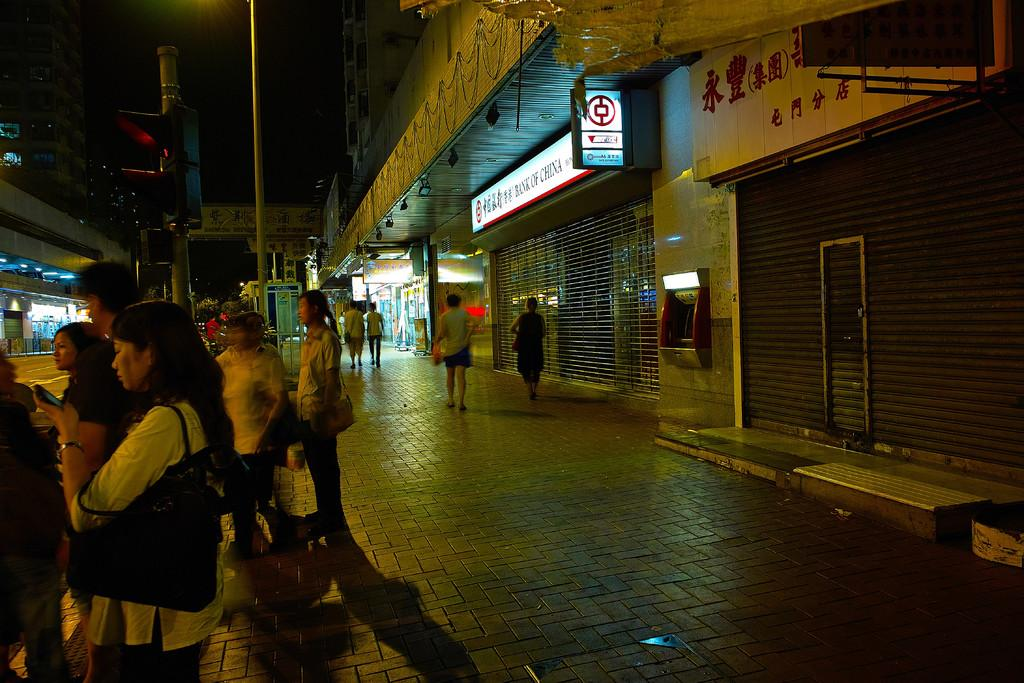What can be seen in the image? There are people in the image. What is the path used for in the image? The path is likely used for walking or transportation in the image. What type of structures are present in the image? There are buildings in the image. What are the boards used for in the image? The boards might be used for signage or construction purposes in the image. What is the pole used for in the image? The pole might be used for hanging signs or supporting structures in the image. What can be seen in the background of the image? Trees and the sky are visible in the background of the image. What type of tin can be seen in the image? There is no tin present in the image. What is the people's fear in the image? There is no indication of fear in the image; the people appear to be going about their activities. 